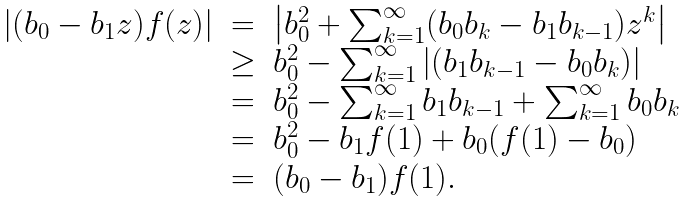Convert formula to latex. <formula><loc_0><loc_0><loc_500><loc_500>\begin{array} { l c l } | ( b _ { 0 } - b _ { 1 } z ) f ( z ) | & = & \left | b _ { 0 } ^ { 2 } + \sum _ { k = 1 } ^ { \infty } ( b _ { 0 } b _ { k } - b _ { 1 } b _ { k - 1 } ) z ^ { k } \right | \\ & \geq & b _ { 0 } ^ { 2 } - \sum _ { k = 1 } ^ { \infty } \left | ( b _ { 1 } b _ { k - 1 } - b _ { 0 } b _ { k } ) \right | \\ & = & b _ { 0 } ^ { 2 } - \sum _ { k = 1 } ^ { \infty } b _ { 1 } b _ { k - 1 } + \sum _ { k = 1 } ^ { \infty } b _ { 0 } b _ { k } \\ & = & b _ { 0 } ^ { 2 } - b _ { 1 } f ( 1 ) + b _ { 0 } ( f ( 1 ) - b _ { 0 } ) \\ & = & ( b _ { 0 } - b _ { 1 } ) f ( 1 ) . \\ \end{array}</formula> 